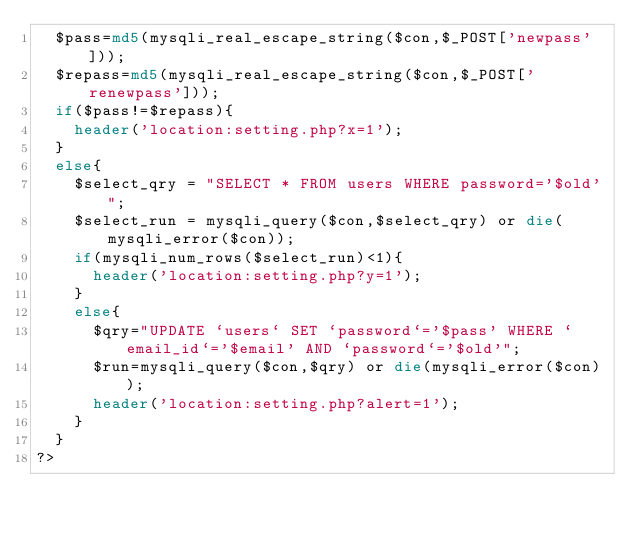Convert code to text. <code><loc_0><loc_0><loc_500><loc_500><_PHP_>	$pass=md5(mysqli_real_escape_string($con,$_POST['newpass']));
	$repass=md5(mysqli_real_escape_string($con,$_POST['renewpass']));
	if($pass!=$repass){
		header('location:setting.php?x=1');
	}
	else{
		$select_qry = "SELECT * FROM users WHERE password='$old'";
		$select_run = mysqli_query($con,$select_qry) or die(mysqli_error($con));
		if(mysqli_num_rows($select_run)<1){
			header('location:setting.php?y=1');
		}
		else{
			$qry="UPDATE `users` SET `password`='$pass' WHERE `email_id`='$email' AND `password`='$old'";
			$run=mysqli_query($con,$qry) or die(mysqli_error($con));
			header('location:setting.php?alert=1');
		}
	}
?></code> 